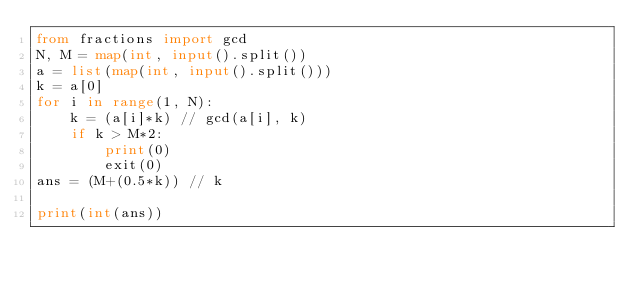Convert code to text. <code><loc_0><loc_0><loc_500><loc_500><_Python_>from fractions import gcd
N, M = map(int, input().split())
a = list(map(int, input().split()))
k = a[0]
for i in range(1, N):
    k = (a[i]*k) // gcd(a[i], k)
    if k > M*2:
        print(0)
        exit(0)
ans = (M+(0.5*k)) // k

print(int(ans))
</code> 